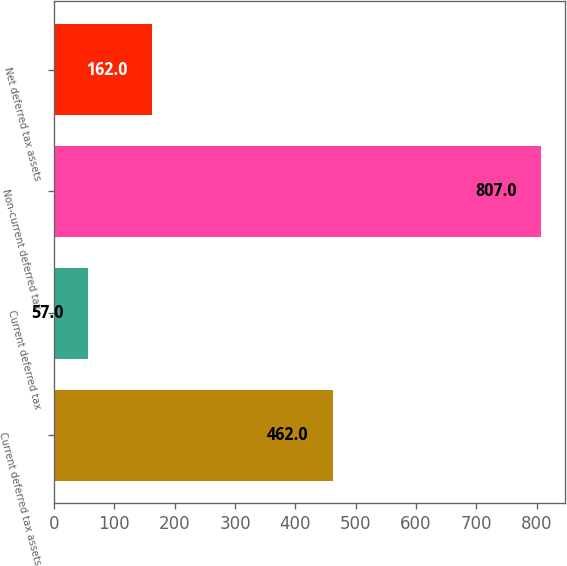Convert chart to OTSL. <chart><loc_0><loc_0><loc_500><loc_500><bar_chart><fcel>Current deferred tax assets<fcel>Current deferred tax<fcel>Non-current deferred tax<fcel>Net deferred tax assets<nl><fcel>462<fcel>57<fcel>807<fcel>162<nl></chart> 